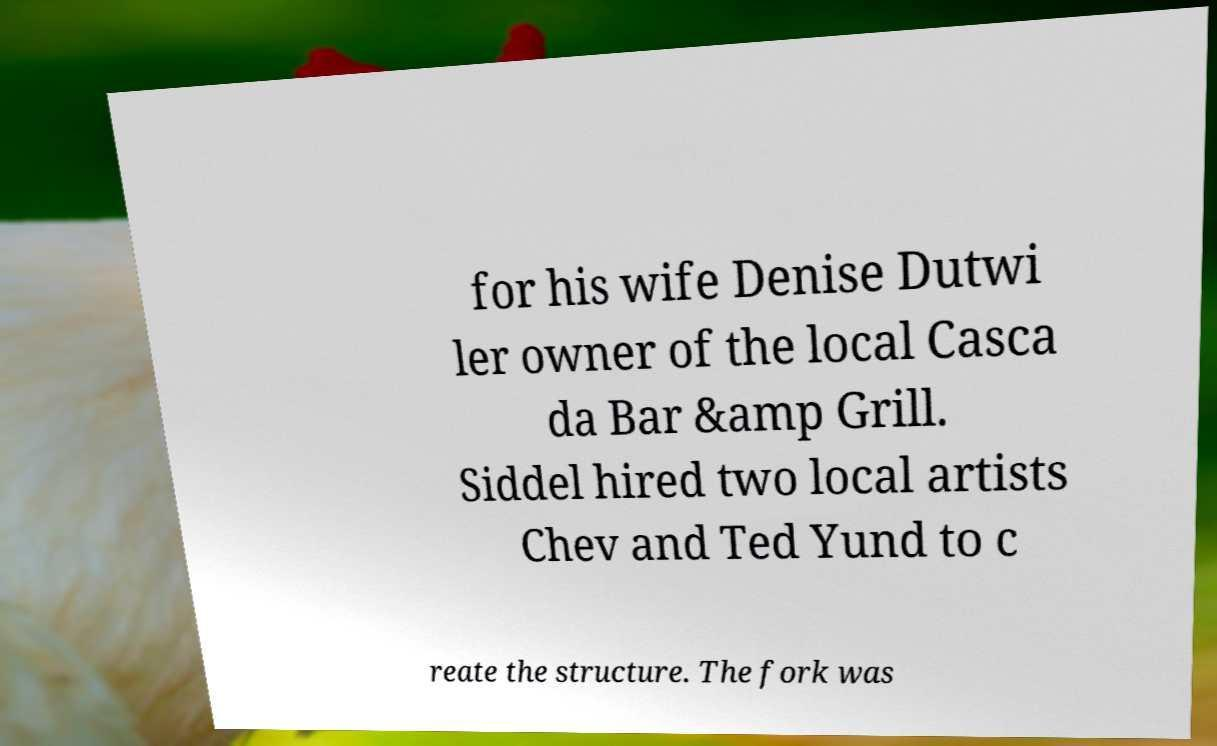There's text embedded in this image that I need extracted. Can you transcribe it verbatim? for his wife Denise Dutwi ler owner of the local Casca da Bar &amp Grill. Siddel hired two local artists Chev and Ted Yund to c reate the structure. The fork was 